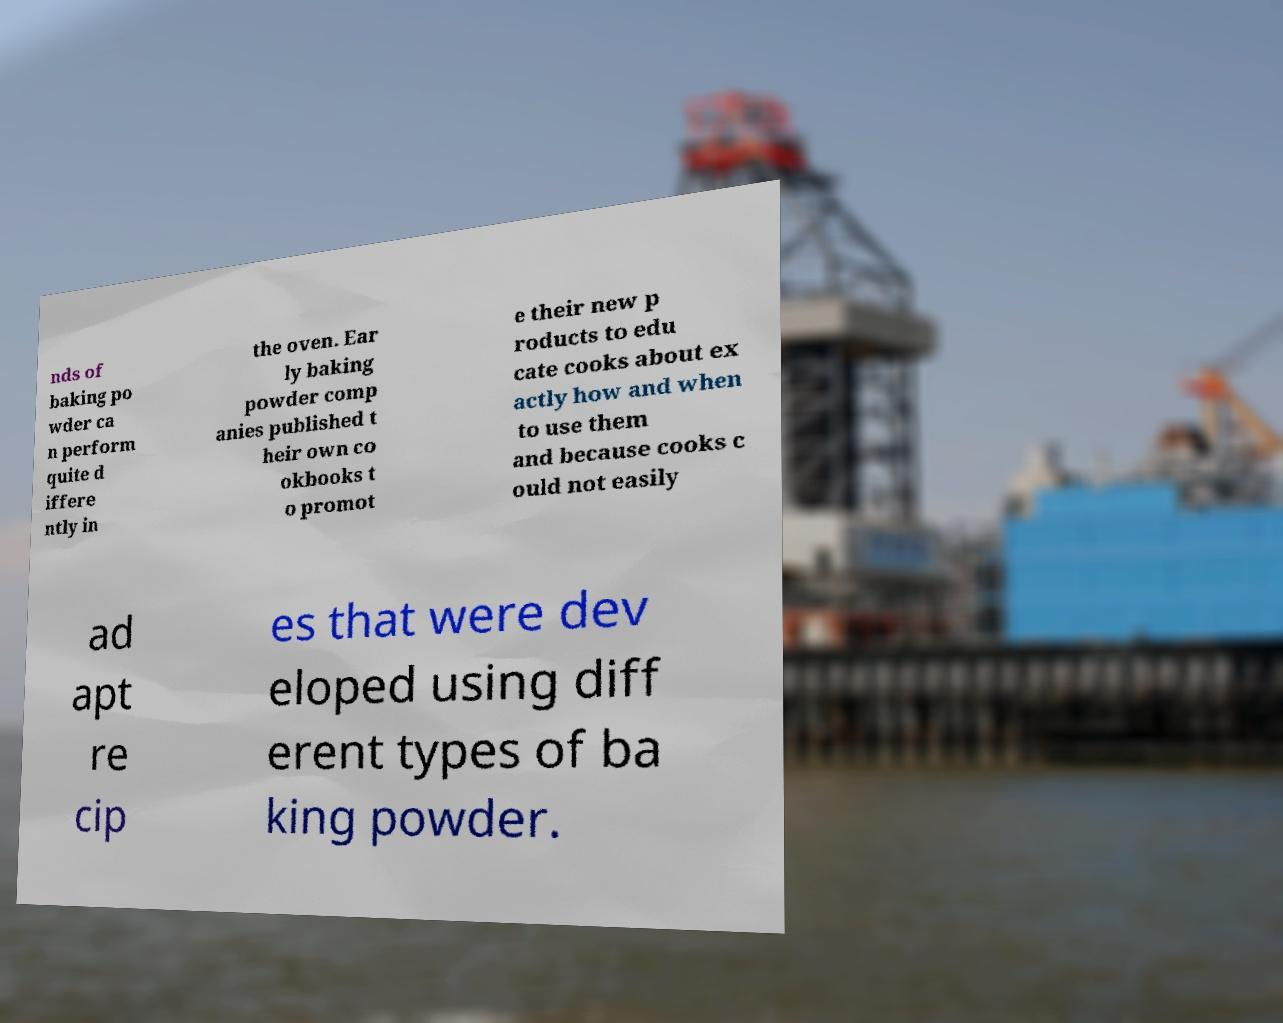I need the written content from this picture converted into text. Can you do that? nds of baking po wder ca n perform quite d iffere ntly in the oven. Ear ly baking powder comp anies published t heir own co okbooks t o promot e their new p roducts to edu cate cooks about ex actly how and when to use them and because cooks c ould not easily ad apt re cip es that were dev eloped using diff erent types of ba king powder. 